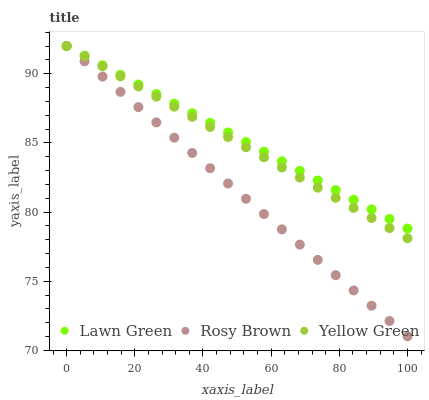Does Rosy Brown have the minimum area under the curve?
Answer yes or no. Yes. Does Lawn Green have the maximum area under the curve?
Answer yes or no. Yes. Does Yellow Green have the minimum area under the curve?
Answer yes or no. No. Does Yellow Green have the maximum area under the curve?
Answer yes or no. No. Is Rosy Brown the smoothest?
Answer yes or no. Yes. Is Yellow Green the roughest?
Answer yes or no. Yes. Is Yellow Green the smoothest?
Answer yes or no. No. Is Rosy Brown the roughest?
Answer yes or no. No. Does Rosy Brown have the lowest value?
Answer yes or no. Yes. Does Yellow Green have the lowest value?
Answer yes or no. No. Does Yellow Green have the highest value?
Answer yes or no. Yes. Does Yellow Green intersect Lawn Green?
Answer yes or no. Yes. Is Yellow Green less than Lawn Green?
Answer yes or no. No. Is Yellow Green greater than Lawn Green?
Answer yes or no. No. 